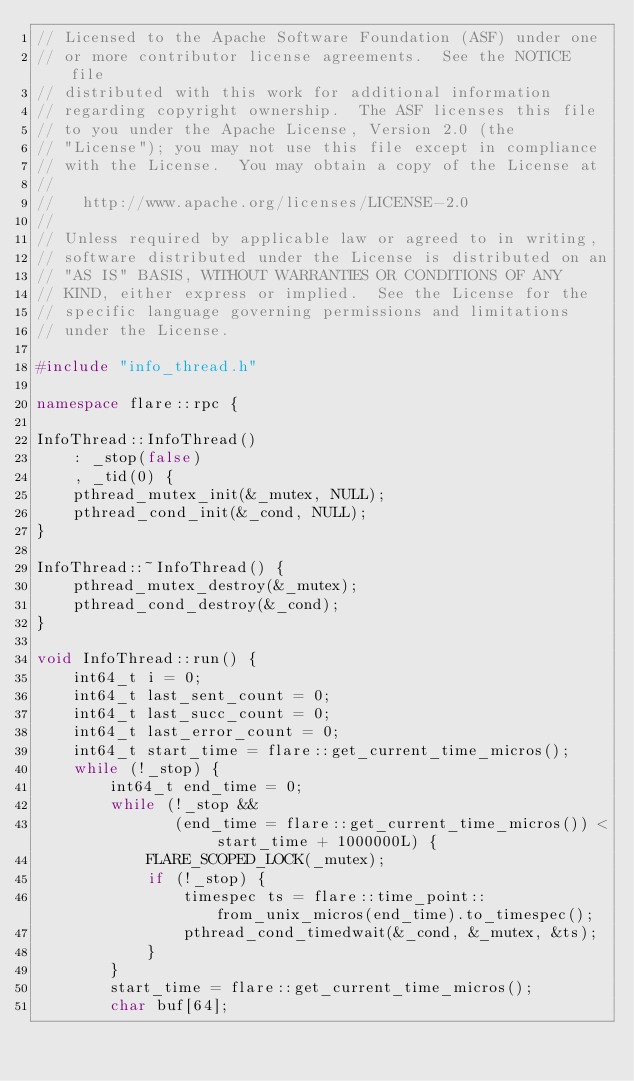Convert code to text. <code><loc_0><loc_0><loc_500><loc_500><_C++_>// Licensed to the Apache Software Foundation (ASF) under one
// or more contributor license agreements.  See the NOTICE file
// distributed with this work for additional information
// regarding copyright ownership.  The ASF licenses this file
// to you under the Apache License, Version 2.0 (the
// "License"); you may not use this file except in compliance
// with the License.  You may obtain a copy of the License at
//
//   http://www.apache.org/licenses/LICENSE-2.0
//
// Unless required by applicable law or agreed to in writing,
// software distributed under the License is distributed on an
// "AS IS" BASIS, WITHOUT WARRANTIES OR CONDITIONS OF ANY
// KIND, either express or implied.  See the License for the
// specific language governing permissions and limitations
// under the License.

#include "info_thread.h"

namespace flare::rpc {

InfoThread::InfoThread()
    : _stop(false)
    , _tid(0) {
    pthread_mutex_init(&_mutex, NULL);
    pthread_cond_init(&_cond, NULL);
}

InfoThread::~InfoThread() {
    pthread_mutex_destroy(&_mutex);
    pthread_cond_destroy(&_cond);
}

void InfoThread::run() {
    int64_t i = 0;
    int64_t last_sent_count = 0;
    int64_t last_succ_count = 0;
    int64_t last_error_count = 0;
    int64_t start_time = flare::get_current_time_micros();
    while (!_stop) {
        int64_t end_time = 0;
        while (!_stop &&
               (end_time = flare::get_current_time_micros()) < start_time + 1000000L) {
            FLARE_SCOPED_LOCK(_mutex);
            if (!_stop) {
                timespec ts = flare::time_point::from_unix_micros(end_time).to_timespec();
                pthread_cond_timedwait(&_cond, &_mutex, &ts);
            }
        }
        start_time = flare::get_current_time_micros();
        char buf[64];</code> 